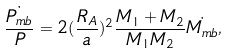<formula> <loc_0><loc_0><loc_500><loc_500>\frac { \dot { P _ { m b } } } { P } = 2 ( \frac { R _ { A } } { a } ) ^ { 2 } \frac { M _ { 1 } + M _ { 2 } } { M _ { 1 } M _ { 2 } } \dot { M _ { m b } } ,</formula> 